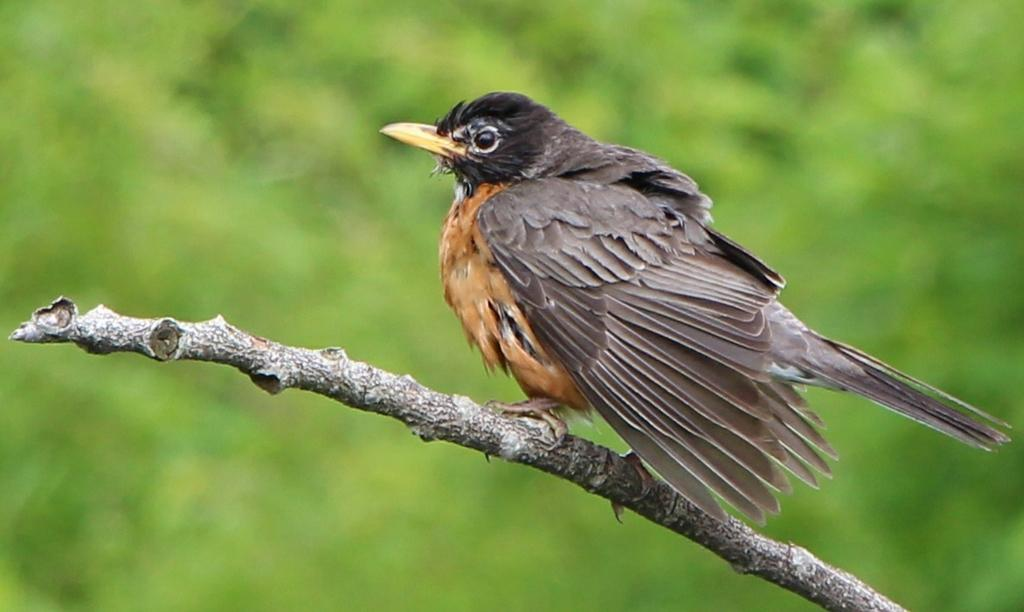What type of animal is in the image? There is a bird in the image. Where is the bird located? The bird is on a stem. What color is the background of the image? The background of the image is green. What type of crate is visible in the image? There is no crate present in the image. What substance is the bird interacting with in the image? The bird is not interacting with any substance in the image; it is simply perched on a stem. 